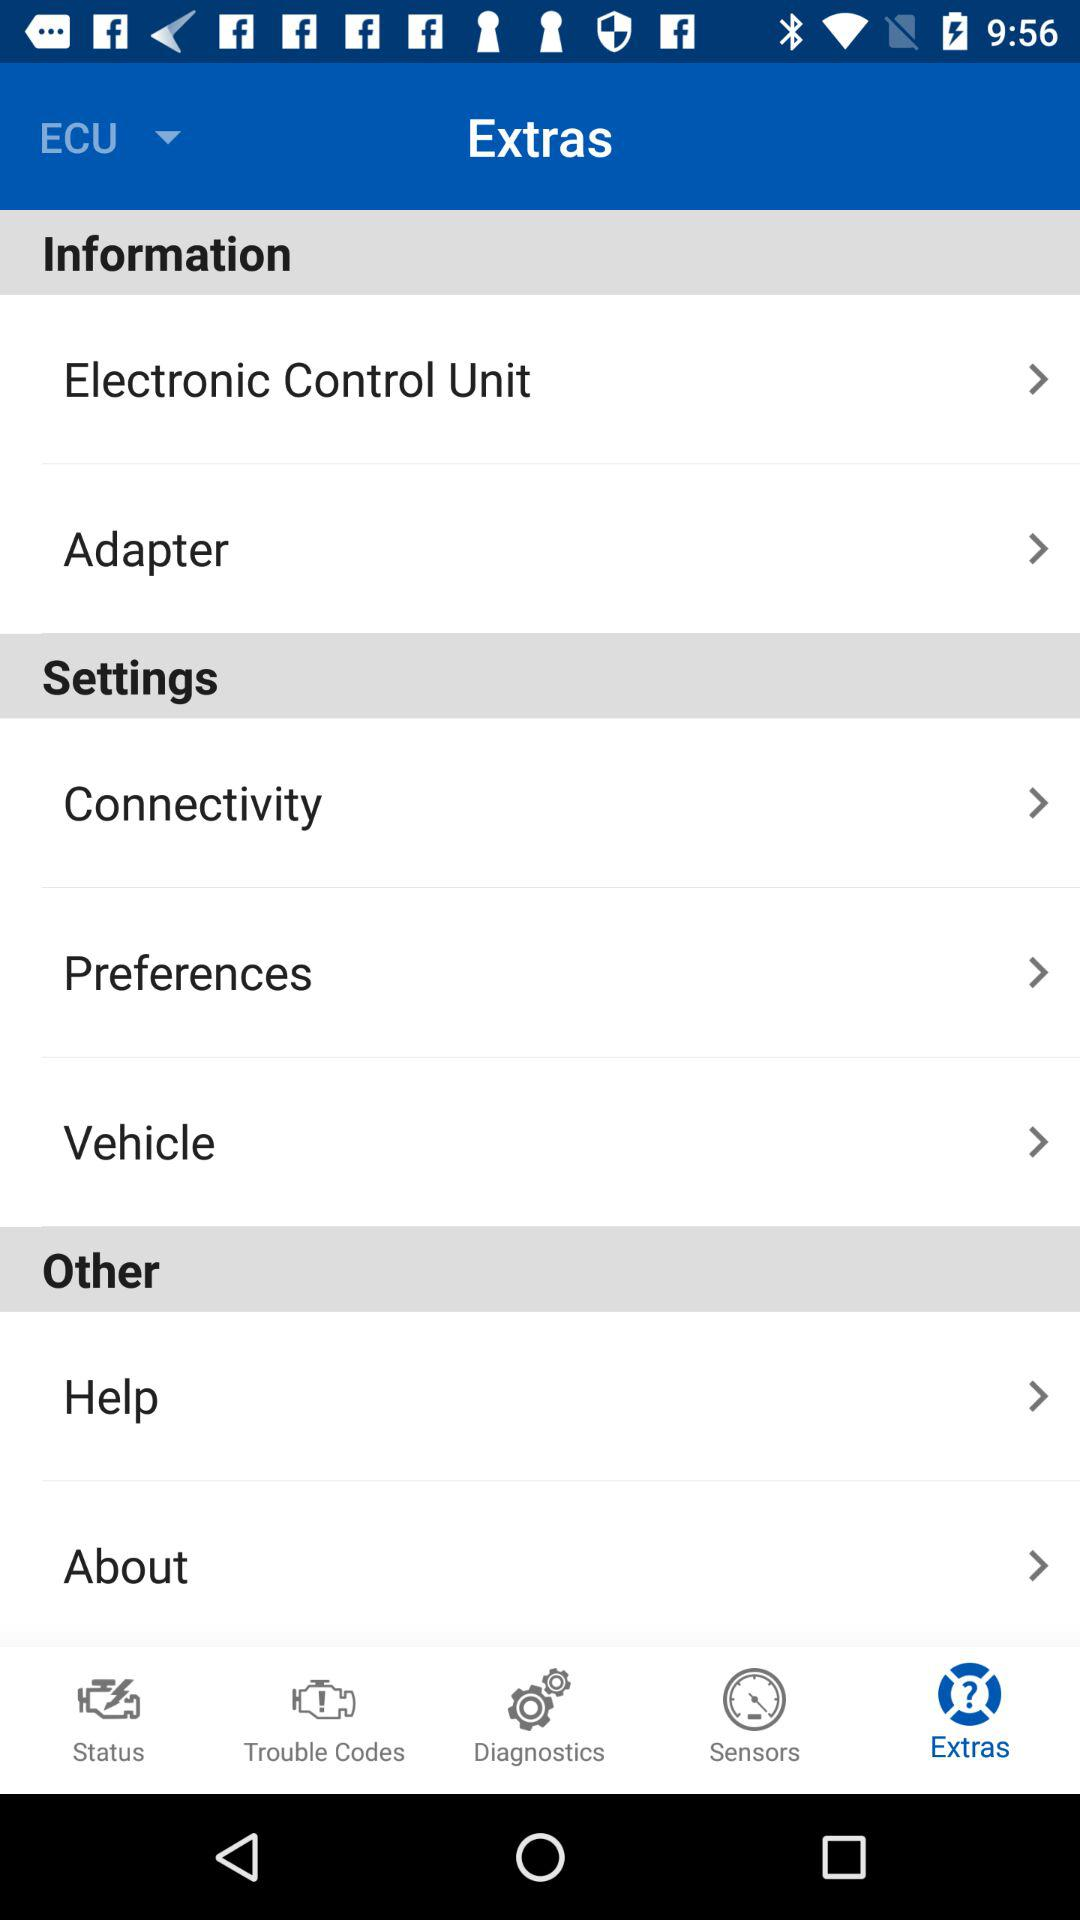What options are available in "Settings"? The available options are "Connectivity", "Preferences", and "Vehicle". 